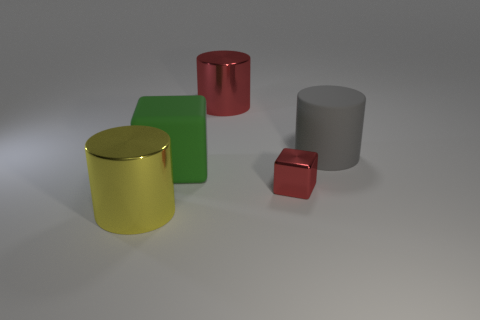Subtract all large gray cylinders. How many cylinders are left? 2 Add 1 tiny purple metallic spheres. How many objects exist? 6 Subtract all cubes. How many objects are left? 3 Add 5 big rubber objects. How many big rubber objects exist? 7 Subtract 0 cyan balls. How many objects are left? 5 Subtract all brown cylinders. Subtract all red balls. How many cylinders are left? 3 Subtract all large gray blocks. Subtract all shiny blocks. How many objects are left? 4 Add 1 large matte objects. How many large matte objects are left? 3 